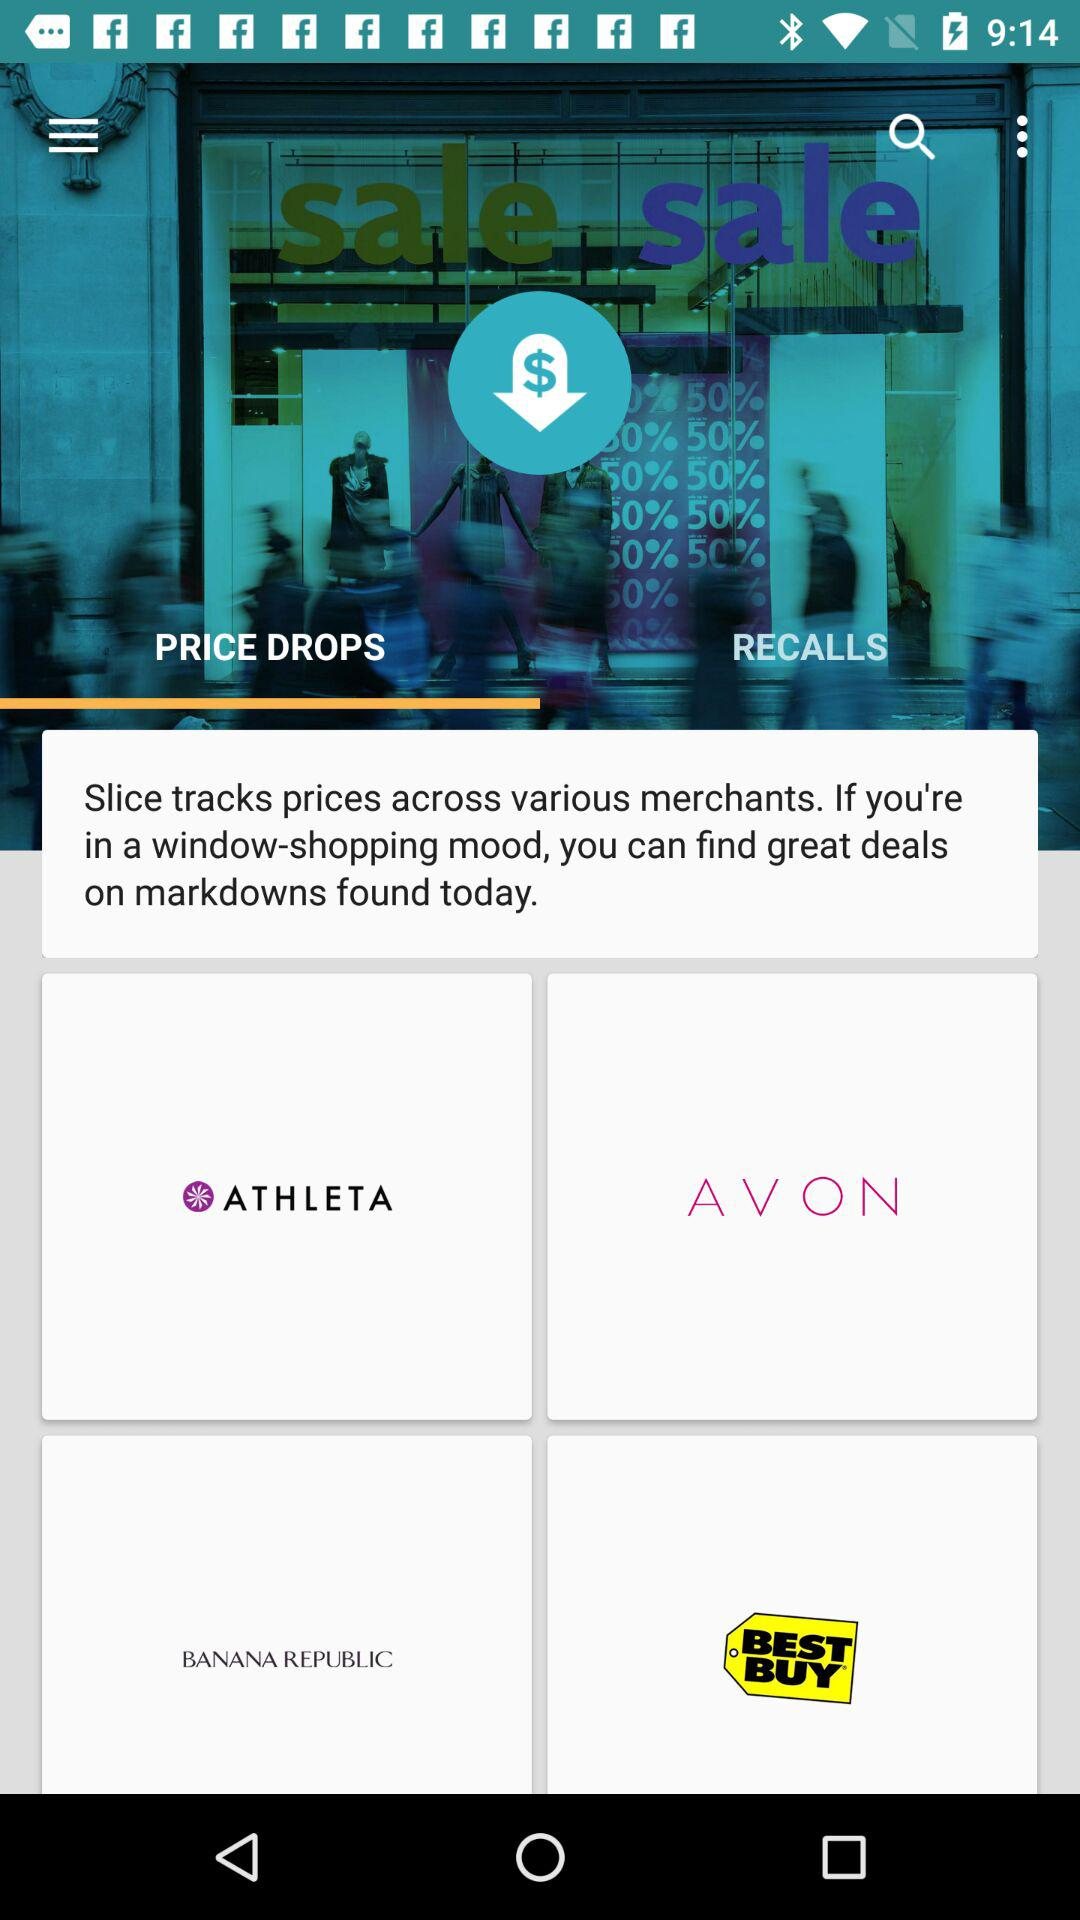Which tab has been selected? The tab that has been selected is "PRICE DROPS". 